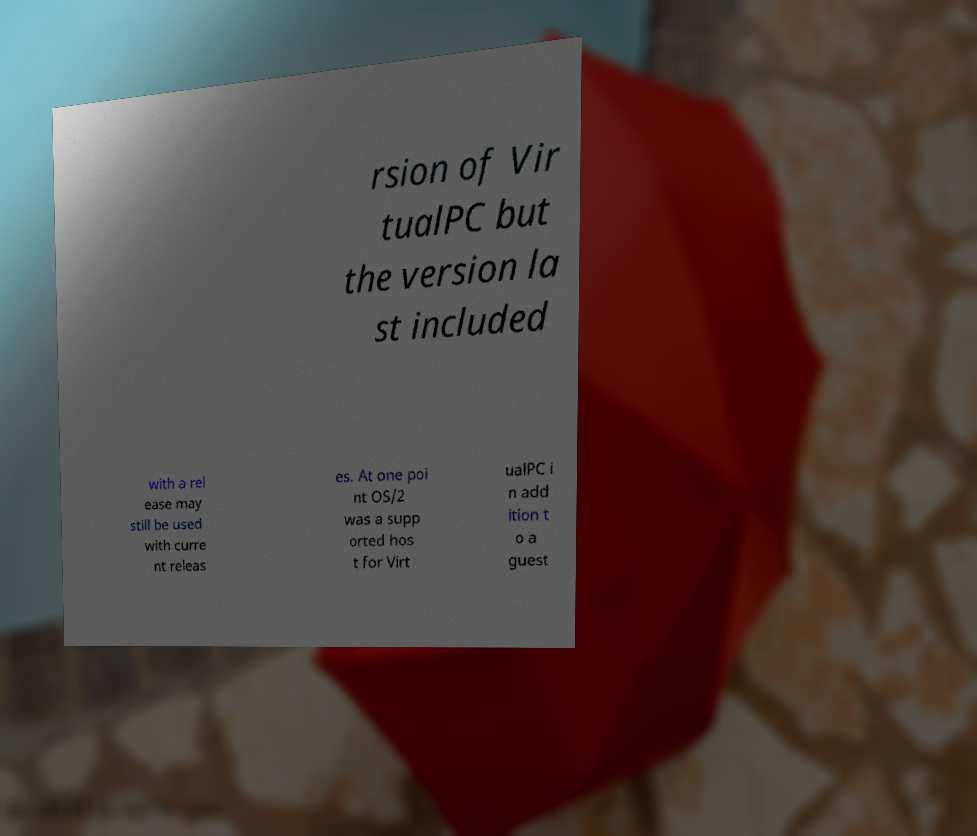I need the written content from this picture converted into text. Can you do that? rsion of Vir tualPC but the version la st included with a rel ease may still be used with curre nt releas es. At one poi nt OS/2 was a supp orted hos t for Virt ualPC i n add ition t o a guest 